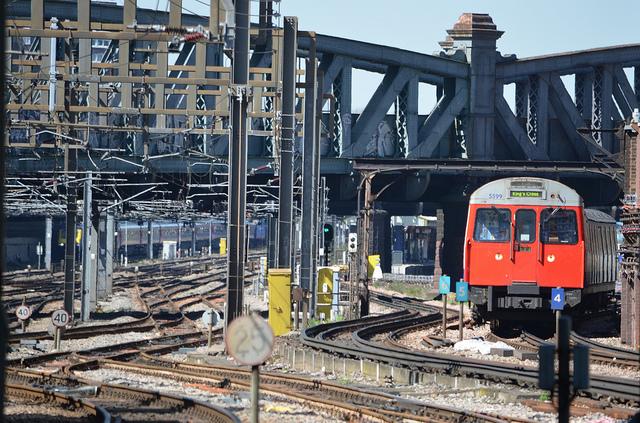What is the train on?
Concise answer only. Tracks. Is this a passenger train or a freight train?
Concise answer only. Passenger. How many tracks are there?
Give a very brief answer. 4. 